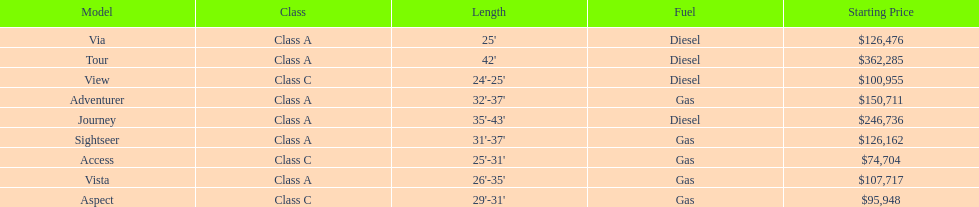Does the tour take diesel or gas? Diesel. 